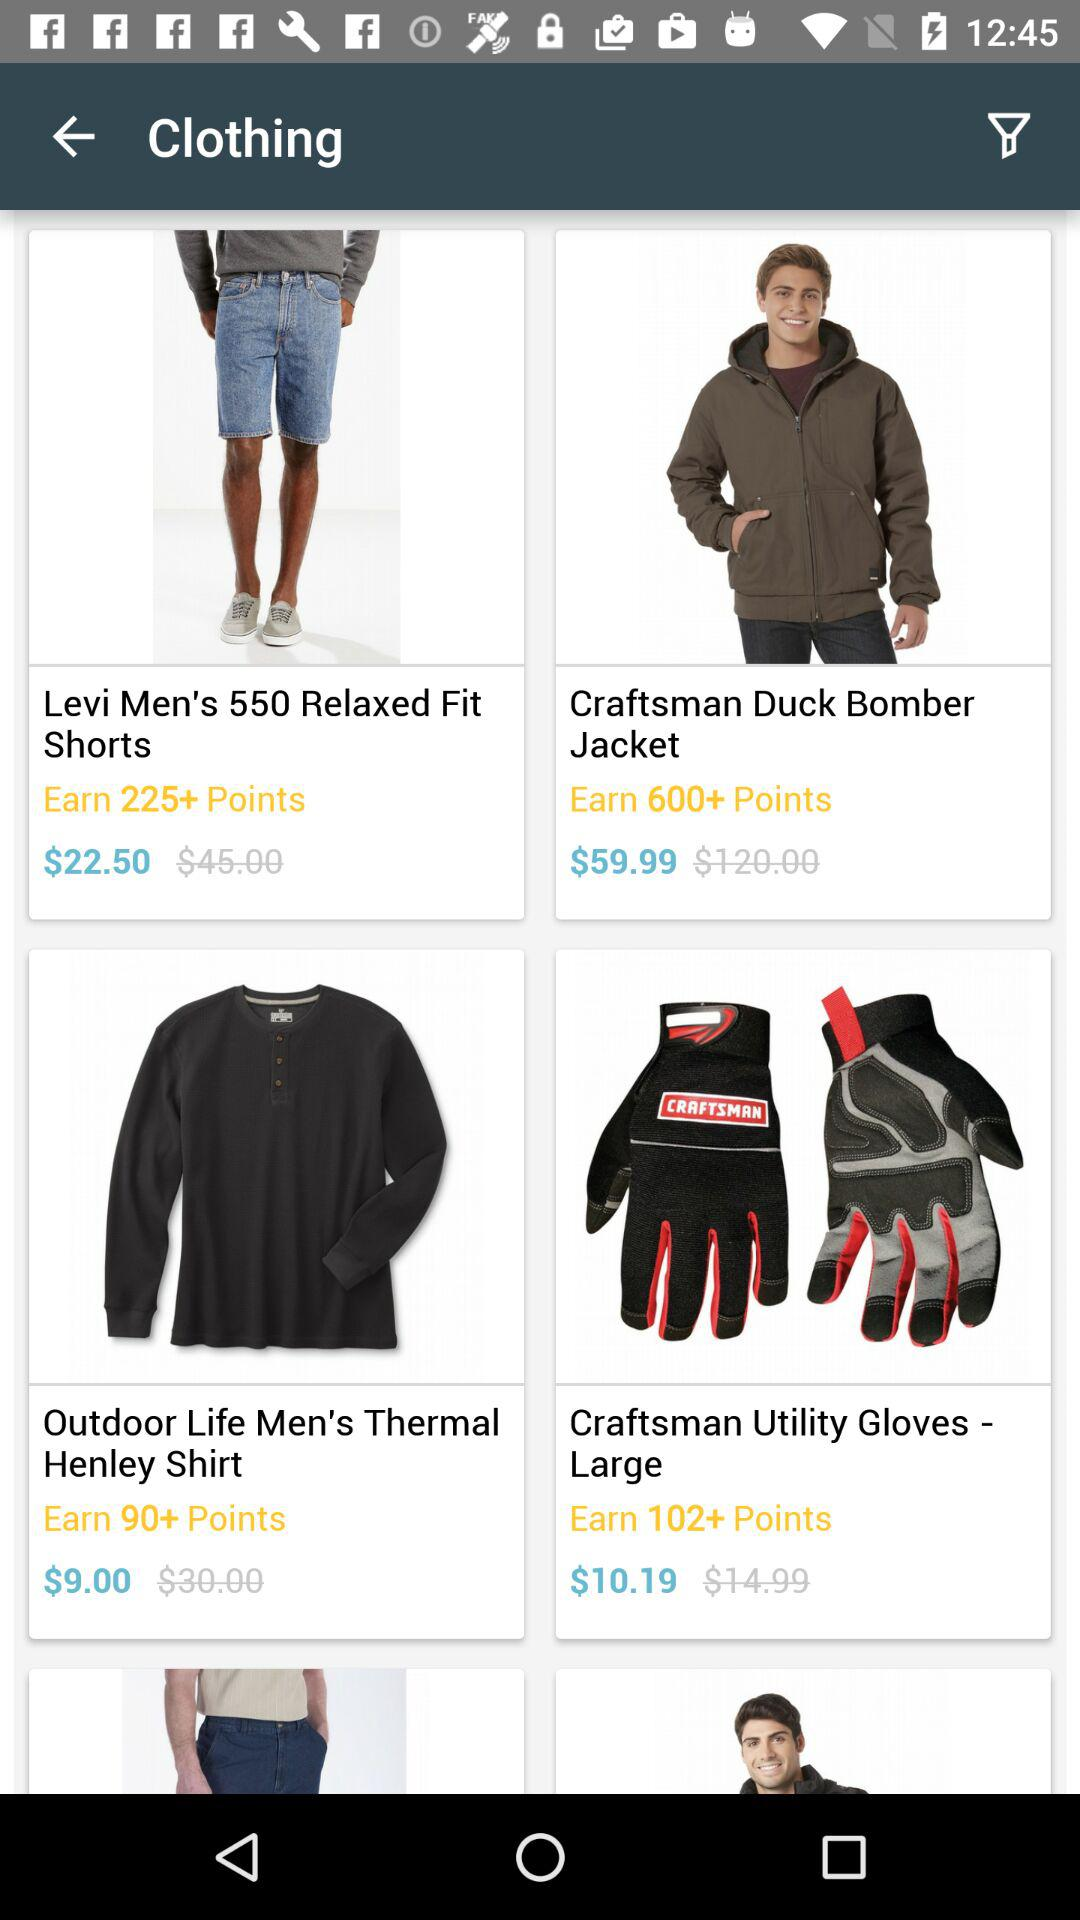How many points can be earned by buying gloves? The number of points that can be earned are more than 102. 